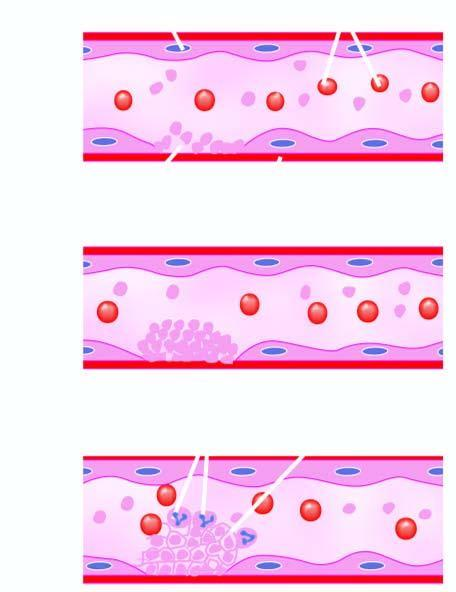what is some leucocytes and red cells and a tight meshwork formed called?
Answer the question using a single word or phrase. Thrombus 